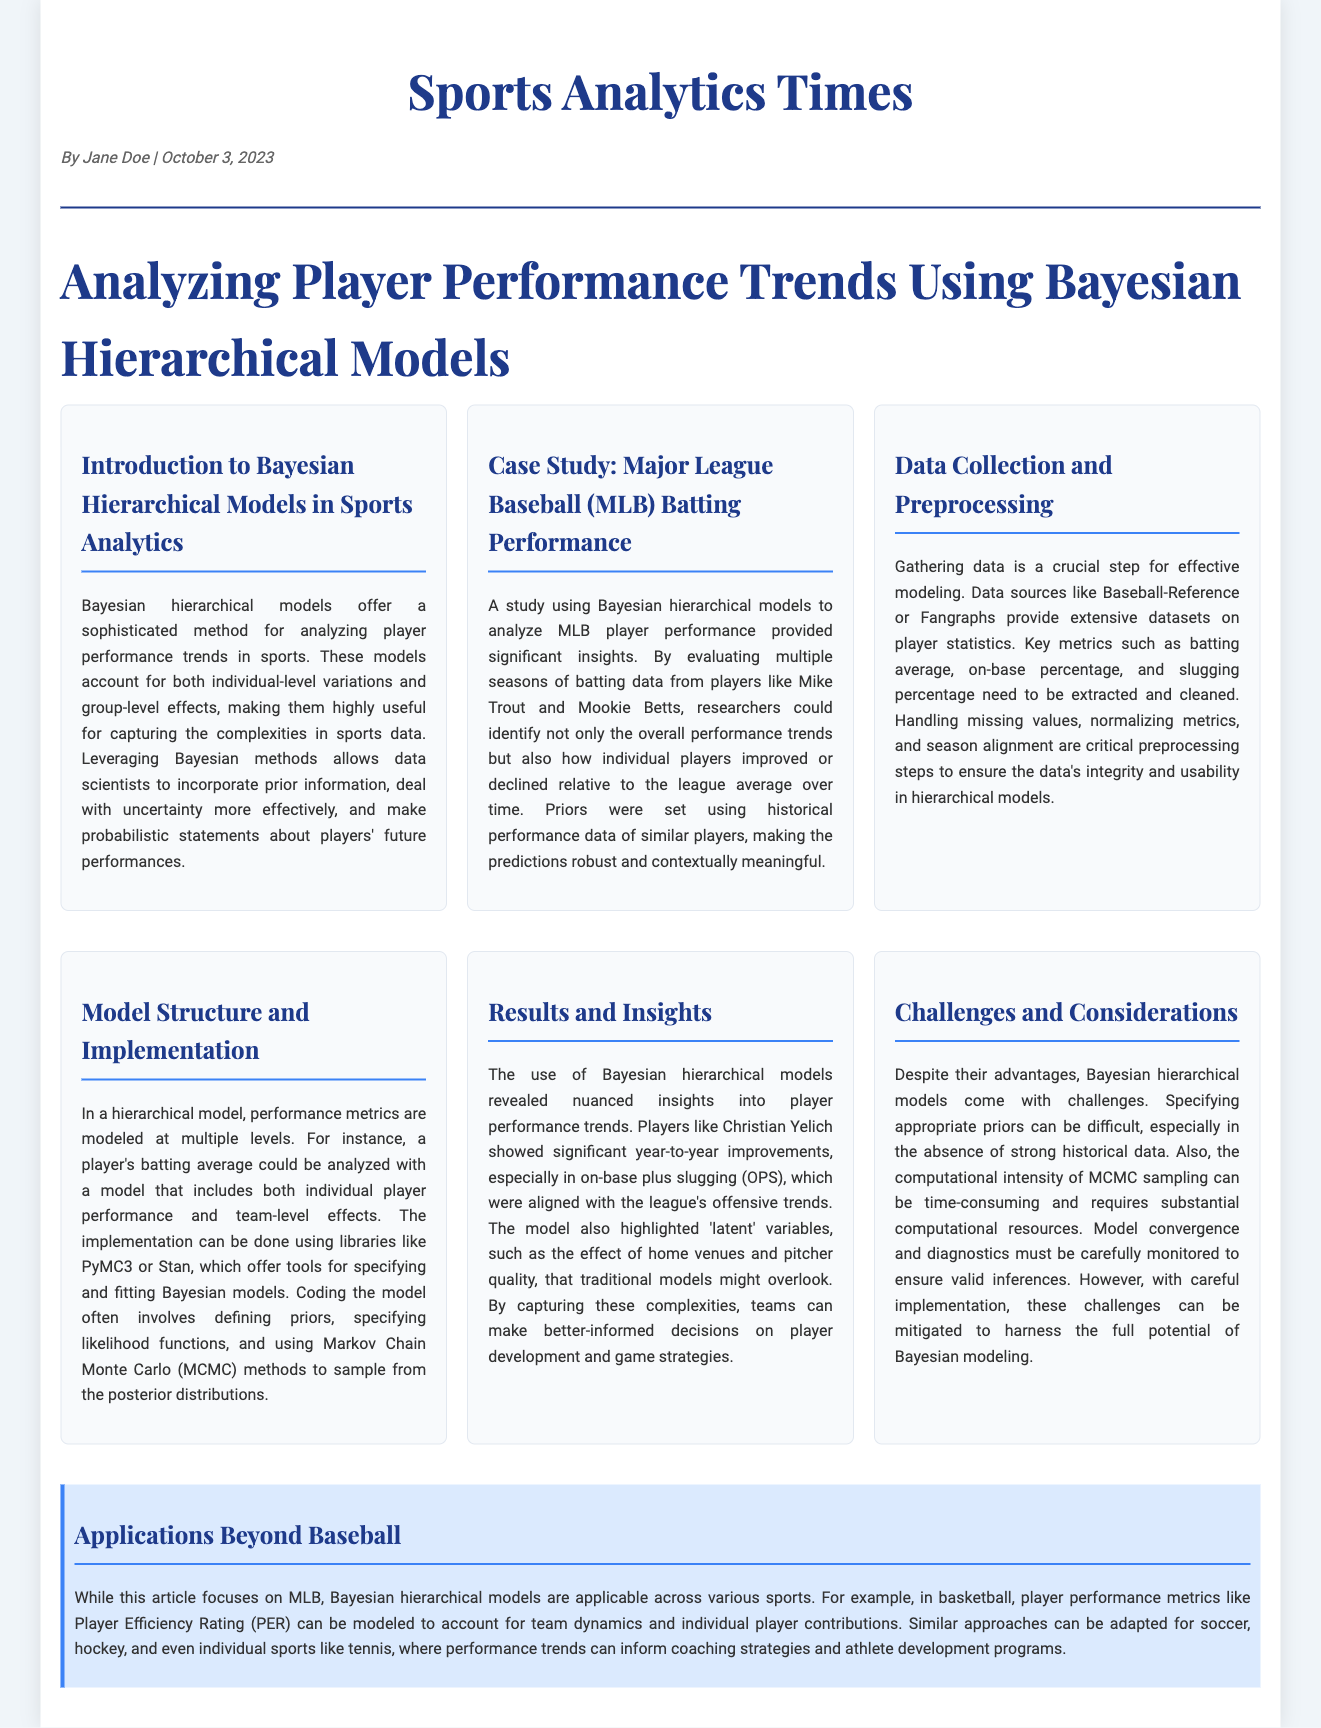what is the title of the article? The title is prominently displayed at the top of the document, indicating the main topic of the article.
Answer: Analyzing Player Performance Trends Using Bayesian Hierarchical Models who is the author of the article? The author's name is listed in the meta section under the title of the newspaper.
Answer: Jane Doe what date was the article published? The publication date is noted in the meta section of the document along with the author's name.
Answer: October 3, 2023 which statistical methods are highlighted in the case study? The case study mentions specific statistical methods applied to analyze player performance.
Answer: Bayesian hierarchical models what performance metrics are mentioned in the data collection section? The article outlines important statistics to consider for modeling player performance during the data collection phase.
Answer: batting average, on-base percentage, slugging percentage what challenge is associated with Bayesian hierarchical models? The section discussing challenges highlights difficulties encountered when applying these models.
Answer: Specifying appropriate priors which players' performances were analyzed in the case study? The case study gives specific examples of players whose data was analyzed through Bayesian hierarchical modeling.
Answer: Mike Trout and Mookie Betts how can Bayesian hierarchical models be utilized in sports beyond baseball? The document elaborates on the versatility of these models across different sports applications.
Answer: basketball, soccer, hockey, tennis 